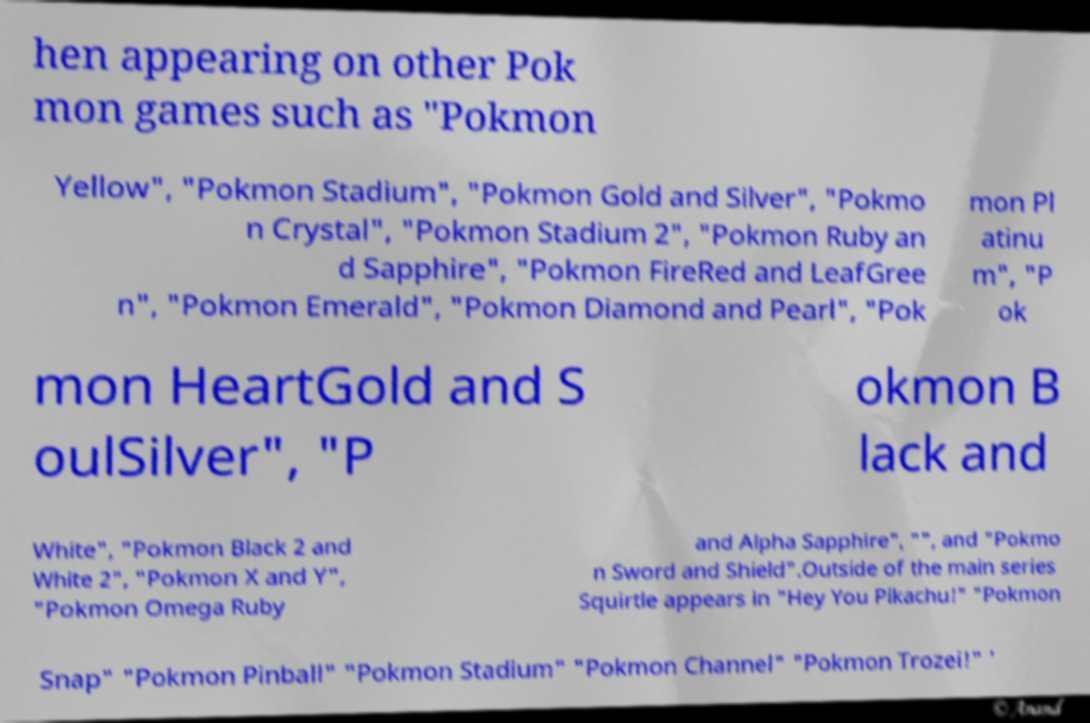Could you extract and type out the text from this image? hen appearing on other Pok mon games such as "Pokmon Yellow", "Pokmon Stadium", "Pokmon Gold and Silver", "Pokmo n Crystal", "Pokmon Stadium 2", "Pokmon Ruby an d Sapphire", "Pokmon FireRed and LeafGree n", "Pokmon Emerald", "Pokmon Diamond and Pearl", "Pok mon Pl atinu m", "P ok mon HeartGold and S oulSilver", "P okmon B lack and White", "Pokmon Black 2 and White 2", "Pokmon X and Y", "Pokmon Omega Ruby and Alpha Sapphire", "", and "Pokmo n Sword and Shield".Outside of the main series Squirtle appears in "Hey You Pikachu!" "Pokmon Snap" "Pokmon Pinball" "Pokmon Stadium" "Pokmon Channel" "Pokmon Trozei!" ' 